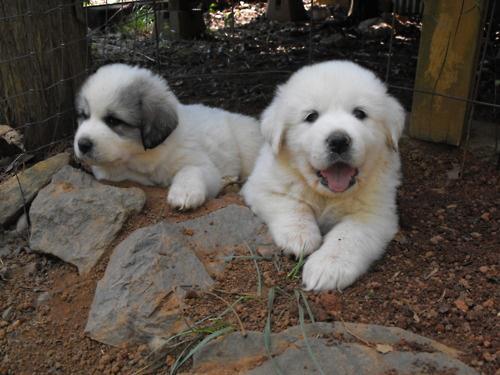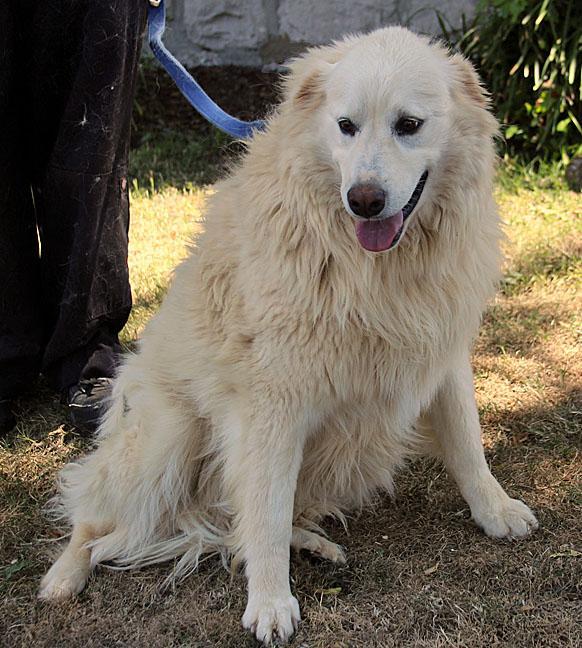The first image is the image on the left, the second image is the image on the right. Evaluate the accuracy of this statement regarding the images: "There are at most two dogs.". Is it true? Answer yes or no. No. The first image is the image on the left, the second image is the image on the right. Given the left and right images, does the statement "One image shows a single sitting white dog, and the other image contains multiple white dogs that are all puppies." hold true? Answer yes or no. Yes. 